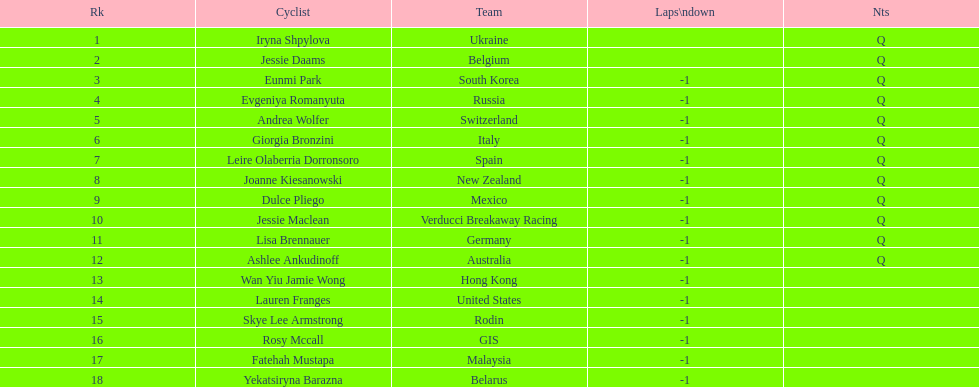What is belgium's numerical ranking? 2. 